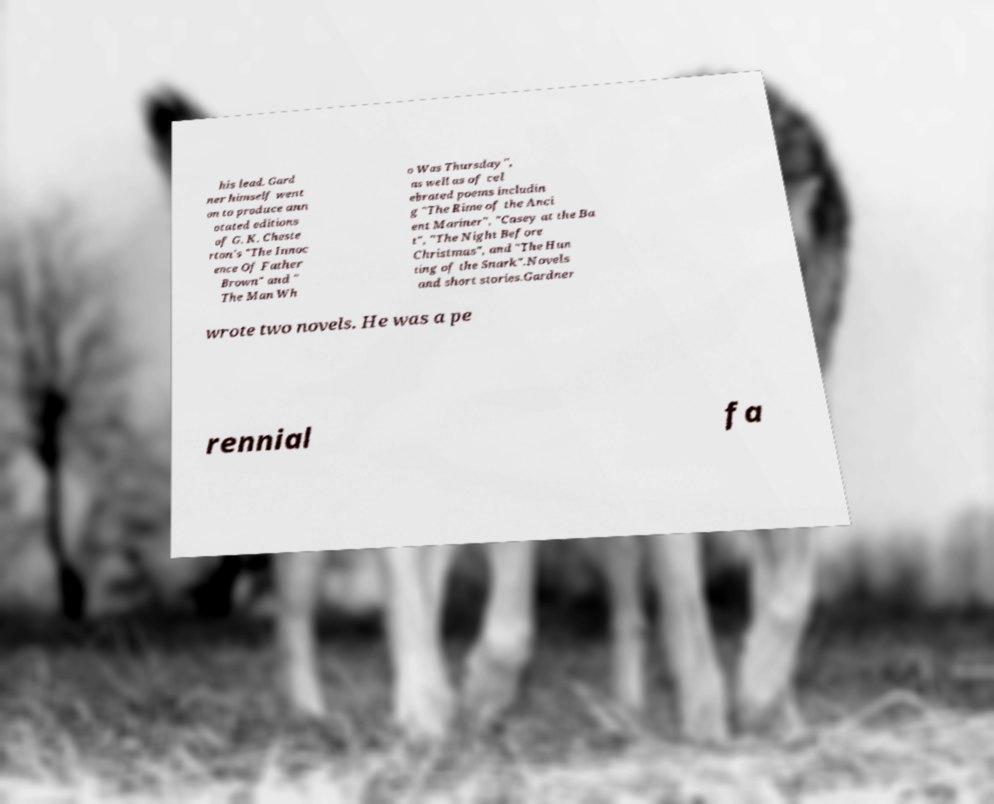Can you read and provide the text displayed in the image?This photo seems to have some interesting text. Can you extract and type it out for me? his lead. Gard ner himself went on to produce ann otated editions of G. K. Cheste rton's "The Innoc ence Of Father Brown" and " The Man Wh o Was Thursday", as well as of cel ebrated poems includin g "The Rime of the Anci ent Mariner", "Casey at the Ba t", "The Night Before Christmas", and "The Hun ting of the Snark".Novels and short stories.Gardner wrote two novels. He was a pe rennial fa 